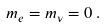Convert formula to latex. <formula><loc_0><loc_0><loc_500><loc_500>m _ { e } = m _ { \nu } = 0 \, .</formula> 